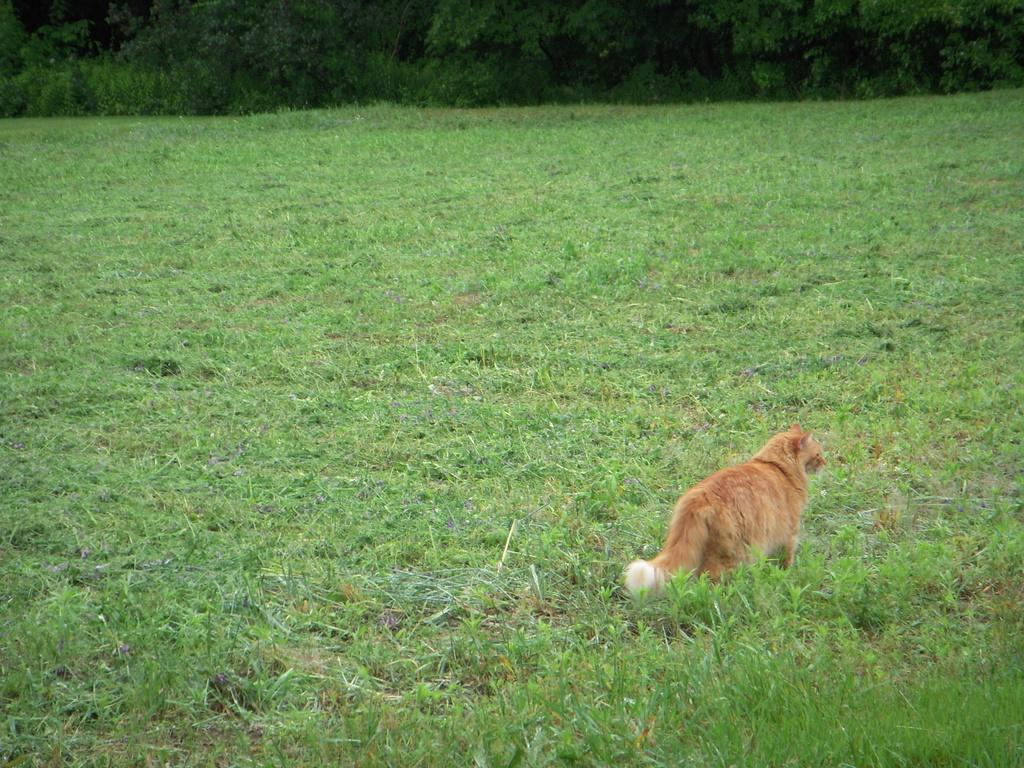What animal is present in the image? There is a cat in the image. Where is the cat located? The cat is standing on the grass. What can be seen in the background of the image? There are trees in the background of the image. What letter does the cat spell out with its body in the image? The cat is not spelling out any letters with its body in the image. 